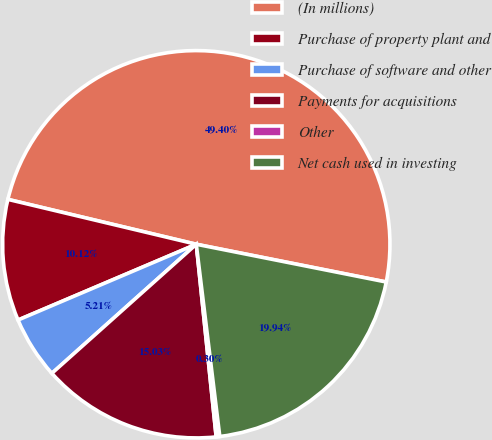Convert chart to OTSL. <chart><loc_0><loc_0><loc_500><loc_500><pie_chart><fcel>(In millions)<fcel>Purchase of property plant and<fcel>Purchase of software and other<fcel>Payments for acquisitions<fcel>Other<fcel>Net cash used in investing<nl><fcel>49.4%<fcel>10.12%<fcel>5.21%<fcel>15.03%<fcel>0.3%<fcel>19.94%<nl></chart> 